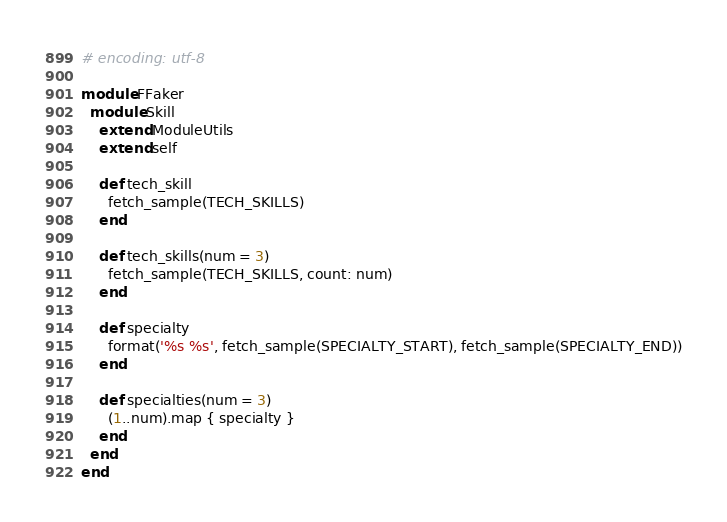Convert code to text. <code><loc_0><loc_0><loc_500><loc_500><_Ruby_># encoding: utf-8

module FFaker
  module Skill
    extend ModuleUtils
    extend self

    def tech_skill
      fetch_sample(TECH_SKILLS)
    end

    def tech_skills(num = 3)
      fetch_sample(TECH_SKILLS, count: num)
    end

    def specialty
      format('%s %s', fetch_sample(SPECIALTY_START), fetch_sample(SPECIALTY_END))
    end

    def specialties(num = 3)
      (1..num).map { specialty }
    end
  end
end
</code> 